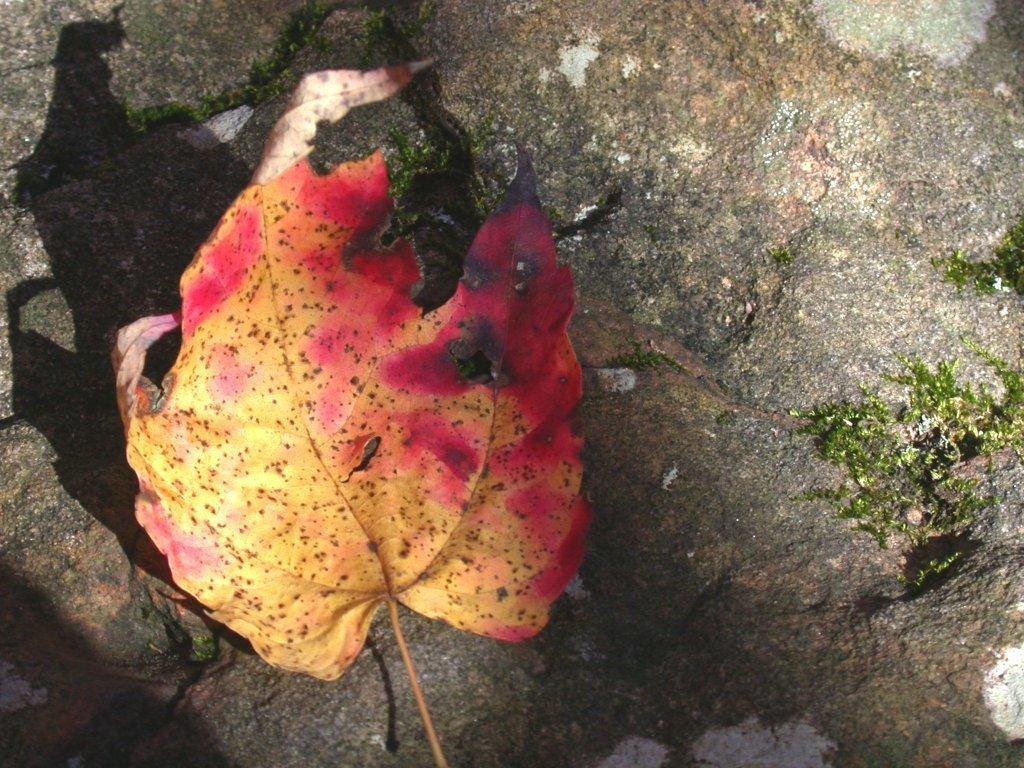Please provide a concise description of this image. In this image we can see the leaf, grass and in the background we can see the rock. 